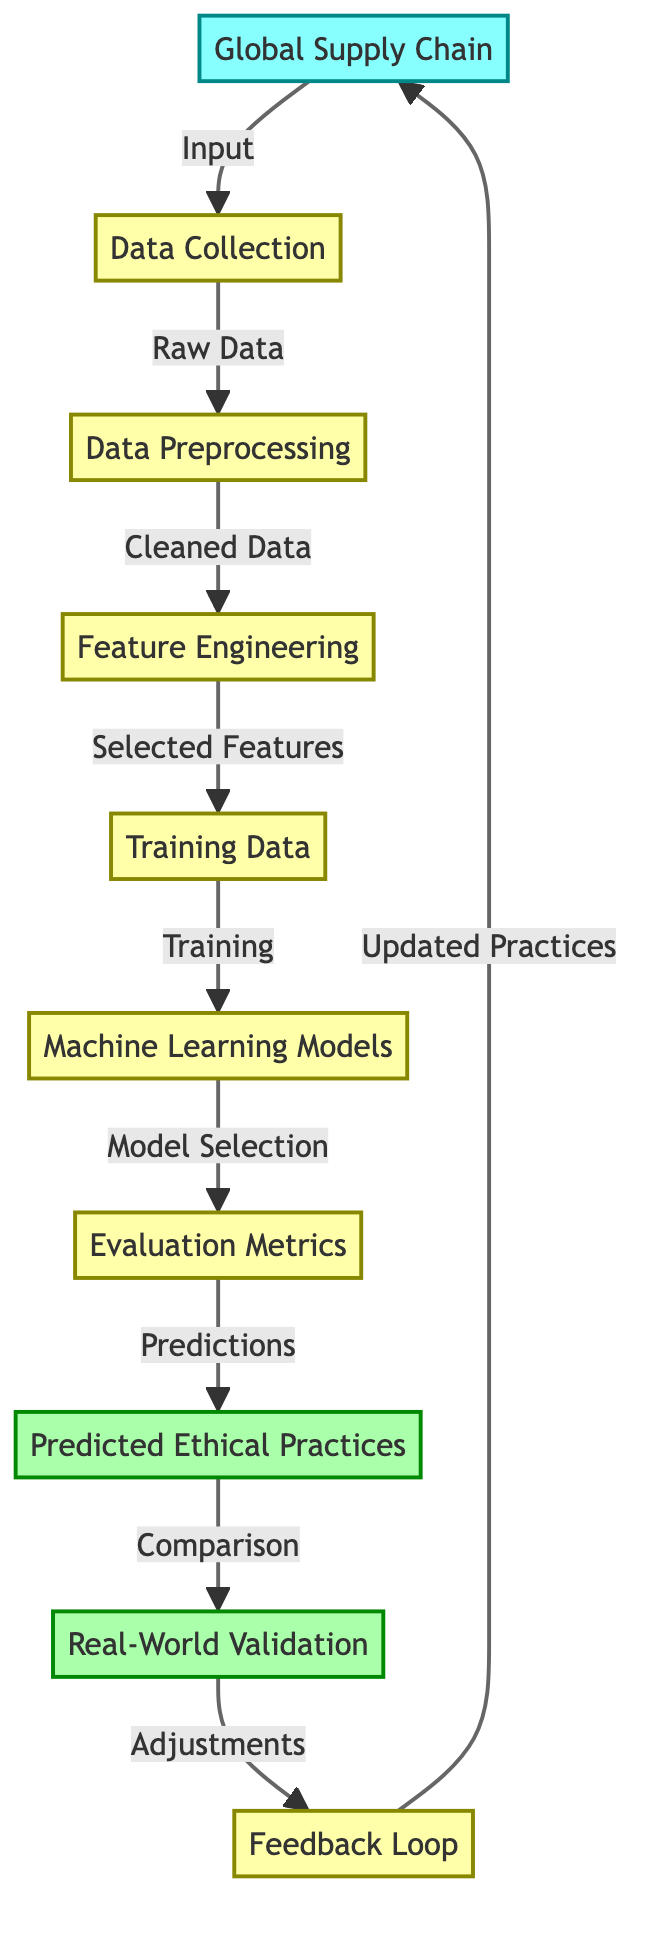What is the starting point of the diagram? The diagram begins with the node labeled "Global Supply Chain," which serves as the input to the process. This is indicated by the input style and positioning at the top of the flowchart.
Answer: Global Supply Chain How many processes are depicted in the diagram? The diagram shows a total of six processes, as indicated by nodes labeled from "Data Collection" to "Feedback Loop." Each of these nodes is categorized under the process style.
Answer: Six What are the outputs of the diagram? The outputs from the diagram are the nodes labeled "Predicted Ethical Practices" and "Real-World Validation," which indicate the end points of the prediction flow.
Answer: Predicted Ethical Practices, Real-World Validation Which node follows "Data Preprocessing"? The node that follows "Data Preprocessing" is "Feature Engineering." This relationship is depicted with an arrow connecting the two nodes in the flowchart, indicating the sequence of processes.
Answer: Feature Engineering How does the "Training Data" relate to "Machine Learning Models"? "Training Data" is the input for the "Machine Learning Models," as represented by the arrow pointing from "Training Data" to "Machine Learning Models." This shows that training data is essential for model training.
Answer: Input What metric is used after "Machine Learning Models"? The diagram shows "Evaluation Metrics" as the direct next step following the "Machine Learning Models." This indicates that models will be assessed based on their performance metrics.
Answer: Evaluation Metrics What happens after "Predicted Ethical Practices"? Following "Predicted Ethical Practices," the next step is "Real-World Validation," which suggests that the predictions made will need to be validated in real-world scenarios.
Answer: Real-World Validation What adjustment is made based on "Real-World Validation"? Based on "Real-World Validation," adjustments are fed back into the "Feedback Loop," indicating that the results of real-world validation will influence future practices.
Answer: Adjustments How many nodes are labeled as output in the diagram? There are two nodes labeled as output in the diagram: "Predicted Ethical Practices" and "Real-World Validation." Each of these nodes is stylized to indicate it functions as an output.
Answer: Two 